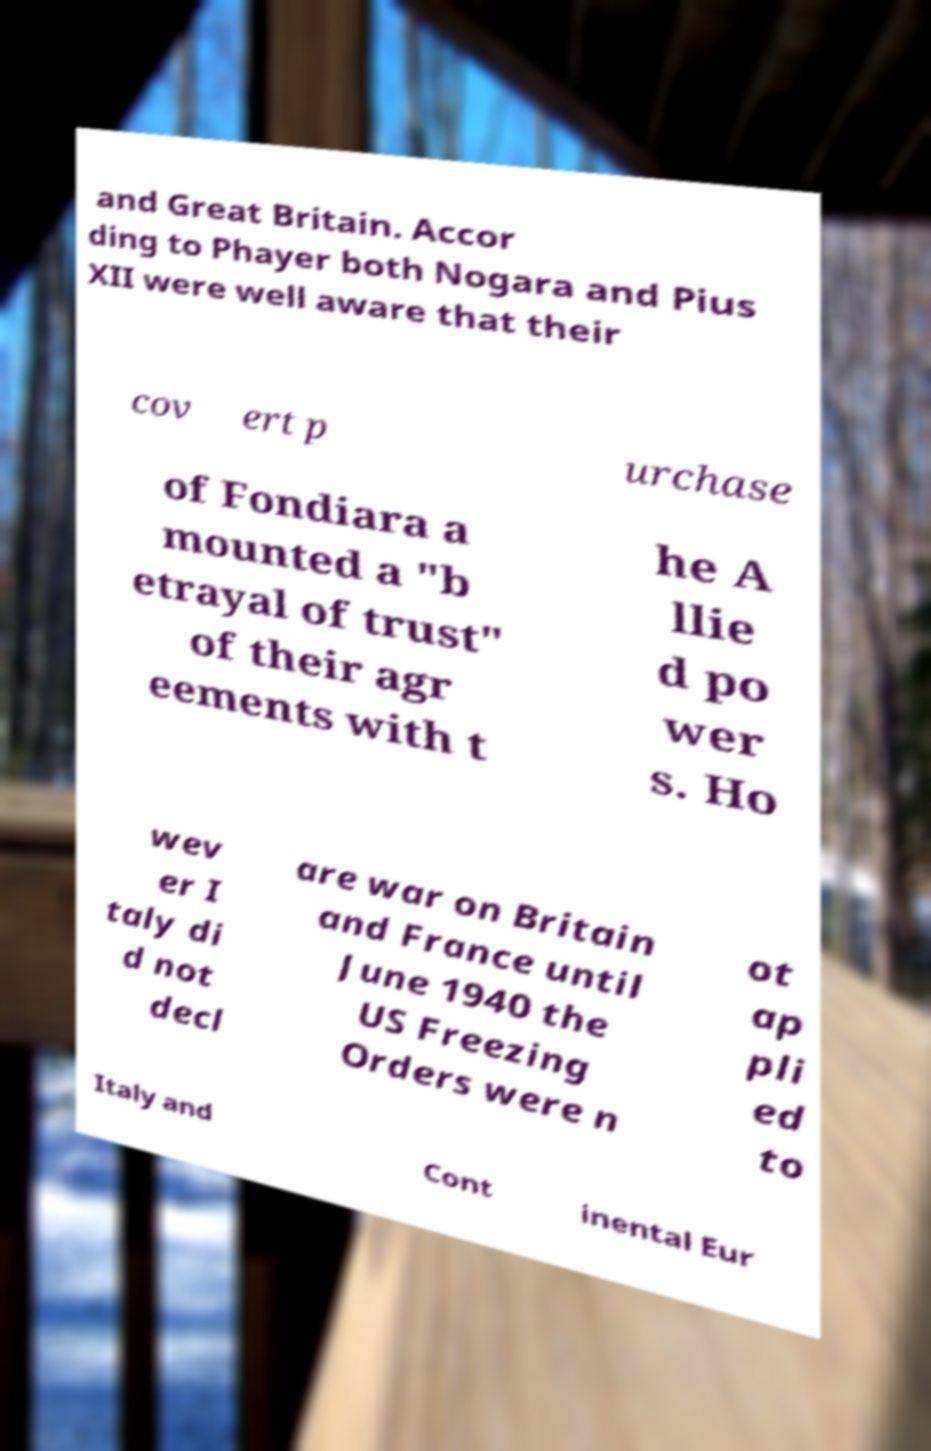What messages or text are displayed in this image? I need them in a readable, typed format. and Great Britain. Accor ding to Phayer both Nogara and Pius XII were well aware that their cov ert p urchase of Fondiara a mounted a "b etrayal of trust" of their agr eements with t he A llie d po wer s. Ho wev er I taly di d not decl are war on Britain and France until June 1940 the US Freezing Orders were n ot ap pli ed to Italy and Cont inental Eur 